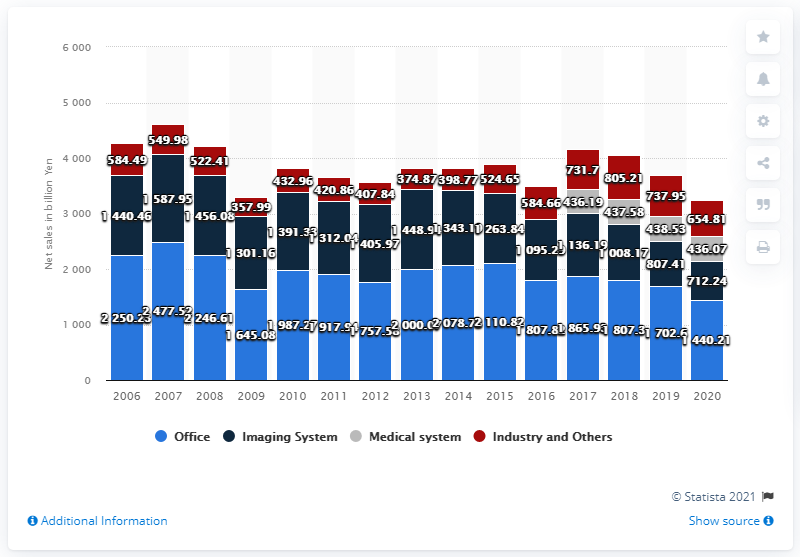Indicate a few pertinent items in this graphic. In 2020, the Imaging Systems segment of Canon generated a total sales revenue of 712.24 million. 